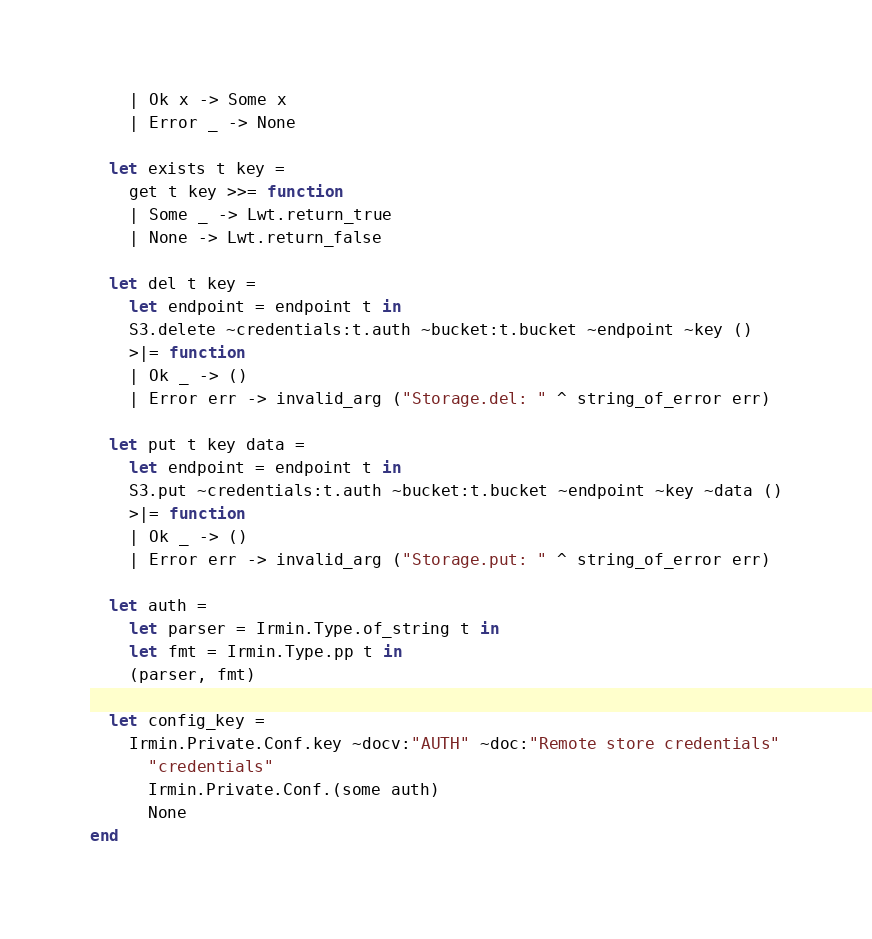Convert code to text. <code><loc_0><loc_0><loc_500><loc_500><_OCaml_>    | Ok x -> Some x
    | Error _ -> None

  let exists t key =
    get t key >>= function
    | Some _ -> Lwt.return_true
    | None -> Lwt.return_false

  let del t key =
    let endpoint = endpoint t in
    S3.delete ~credentials:t.auth ~bucket:t.bucket ~endpoint ~key ()
    >|= function
    | Ok _ -> ()
    | Error err -> invalid_arg ("Storage.del: " ^ string_of_error err)

  let put t key data =
    let endpoint = endpoint t in
    S3.put ~credentials:t.auth ~bucket:t.bucket ~endpoint ~key ~data ()
    >|= function
    | Ok _ -> ()
    | Error err -> invalid_arg ("Storage.put: " ^ string_of_error err)

  let auth =
    let parser = Irmin.Type.of_string t in
    let fmt = Irmin.Type.pp t in
    (parser, fmt)

  let config_key =
    Irmin.Private.Conf.key ~docv:"AUTH" ~doc:"Remote store credentials"
      "credentials"
      Irmin.Private.Conf.(some auth)
      None
end
</code> 